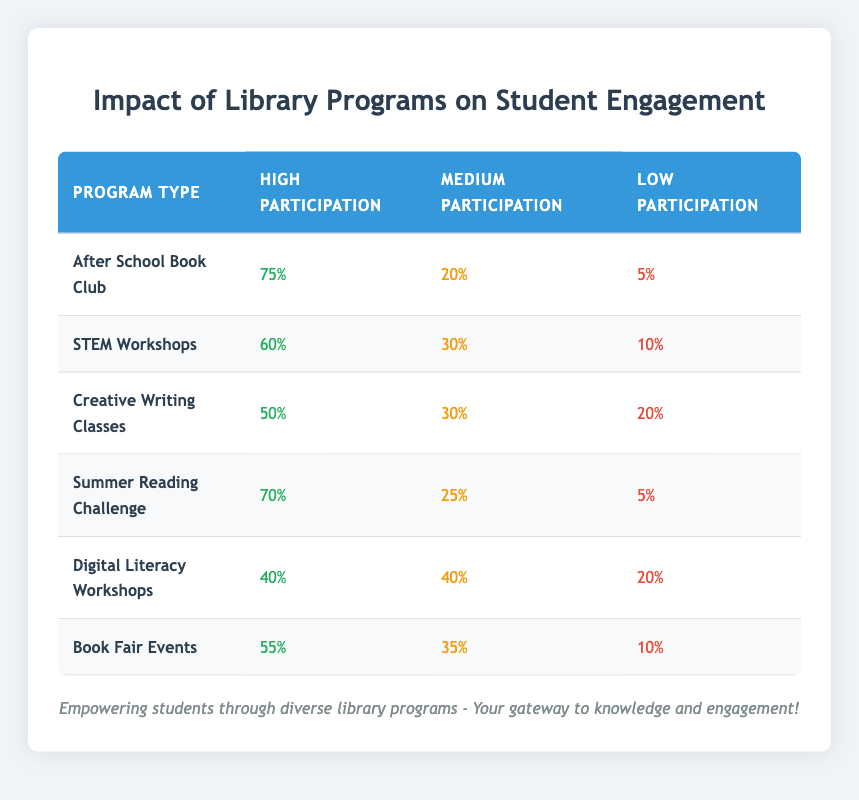What is the participation rate for the After School Book Club in the high category? The table shows that the high participation rate for the After School Book Club is 75%.
Answer: 75% Which program has the highest high participation rate? In the table, the highest high participation rate is for the After School Book Club, with a rate of 75%.
Answer: After School Book Club What is the average medium participation rate across all programs? To find the average, sum the medium participation rates: (20 + 30 + 30 + 25 + 40 + 35) = 210. There are 6 programs, so divide 210 by 6, which gives 35.
Answer: 35 Is the participation rate for Digital Literacy Workshops in the high category greater than that of Creative Writing Classes? The high participation rate for Digital Literacy Workshops is 40%, while for Creative Writing Classes, it is 50%. Since 40% is not greater than 50%, the statement is false.
Answer: No What is the total low participation rate across all programs? To find the total low participation rate, sum the low participation rates: (5 + 10 + 20 + 5 + 20 + 10) = 80.
Answer: 80 Which program has a higher low participation rate: STEM Workshops or Summer Reading Challenge? The low participation rate for STEM Workshops is 10%, while for the Summer Reading Challenge, it is 5%. Since 10% is greater than 5%, STEM Workshops has the higher low participation rate.
Answer: STEM Workshops What percentage of participants in the Creative Writing Classes had a medium level of participation? The table indicates that the medium participation rate for Creative Writing Classes is 30%.
Answer: 30% If we consider only the programs with high participation rates greater than 50%, how many are there? The programs with high participation rates over 50% are After School Book Club (75%), STEM Workshops (60%), Summer Reading Challenge (70%), and Book Fair Events (55%). That totals to 4 programs.
Answer: 4 